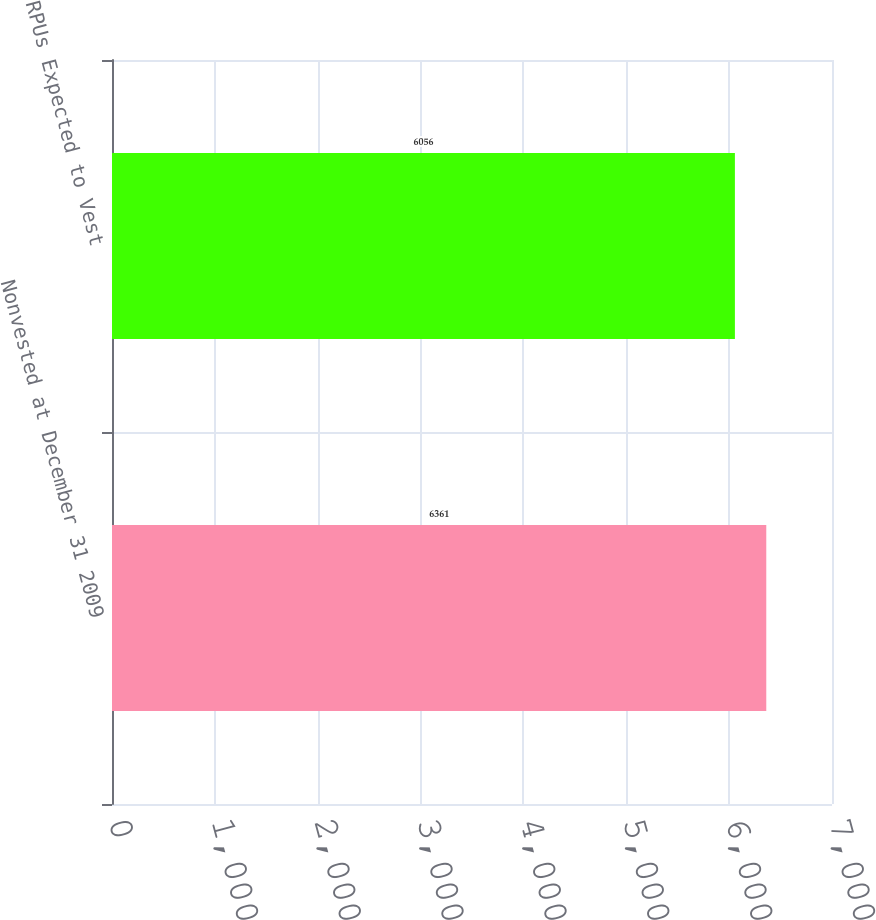<chart> <loc_0><loc_0><loc_500><loc_500><bar_chart><fcel>Nonvested at December 31 2009<fcel>RPUs Expected to Vest<nl><fcel>6361<fcel>6056<nl></chart> 